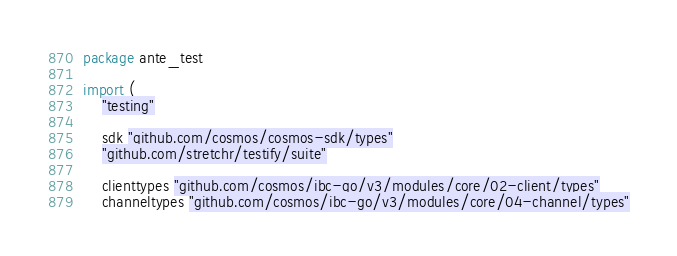<code> <loc_0><loc_0><loc_500><loc_500><_Go_>package ante_test

import (
	"testing"

	sdk "github.com/cosmos/cosmos-sdk/types"
	"github.com/stretchr/testify/suite"

	clienttypes "github.com/cosmos/ibc-go/v3/modules/core/02-client/types"
	channeltypes "github.com/cosmos/ibc-go/v3/modules/core/04-channel/types"</code> 